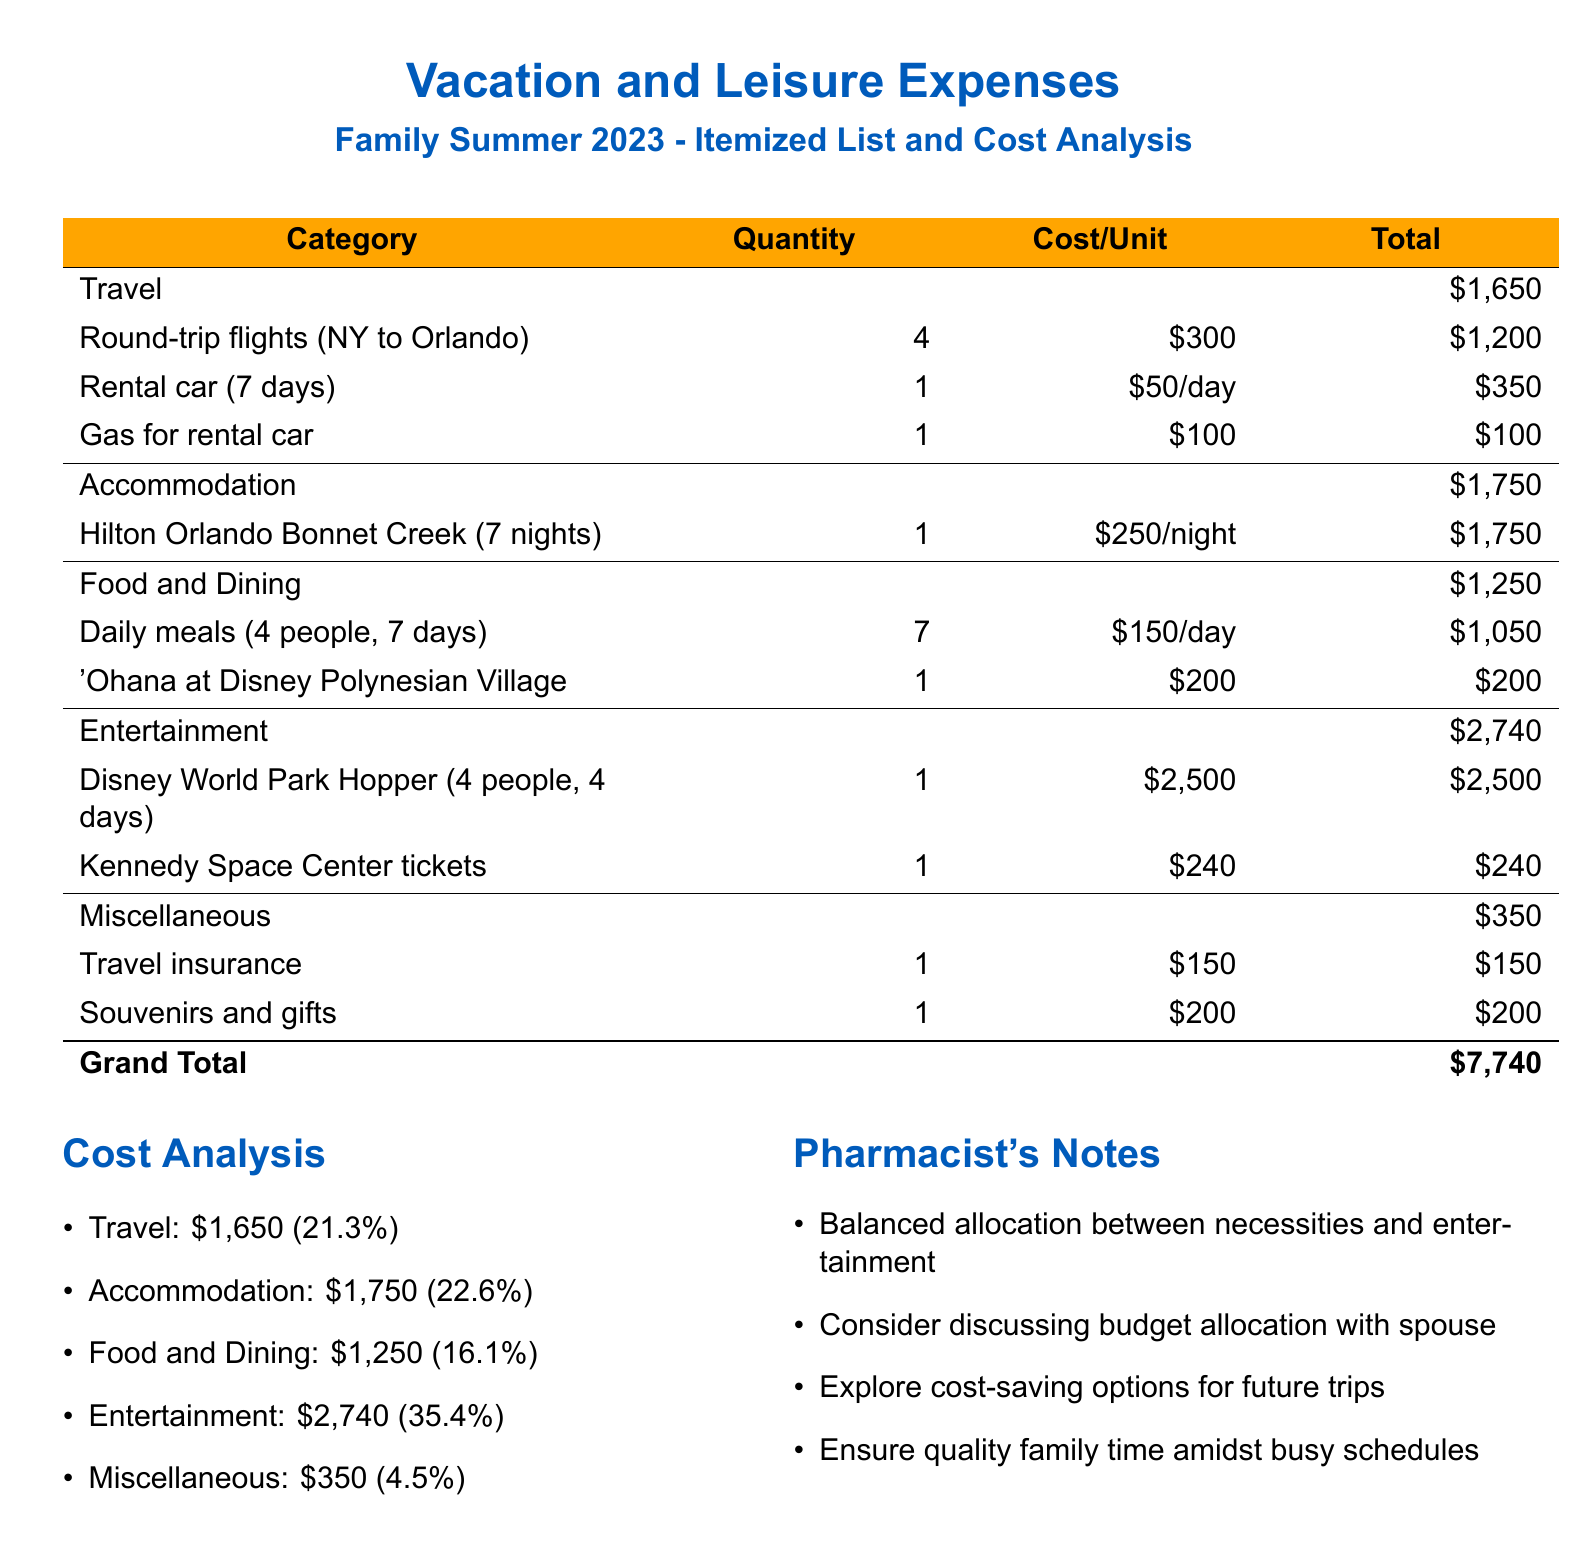What is the total cost of Travel? The total cost of Travel is directly stated in the document, which totals $1,650.
Answer: $1,650 How much was spent on Entertainment? The total spent on Entertainment is indicated in the cost analysis, which is $2,740.
Answer: $2,740 What was the quantity of Round-trip flights? The document specifies that there were 4 Round-trip flights.
Answer: 4 What percentage of the total expenses is Miscellaneous? The expenses are summarized in a list, and Miscellaneous accounts for 4.5% of the total.
Answer: 4.5% How much did the rental car cost per day? The document breaks down the rental car cost, indicating it was $50 per day.
Answer: $50 What is the Grand Total of the expenses? The Grand Total of the expenses is clearly listed in the table as $7,740.
Answer: $7,740 How many days was the rental car booked for? The rental car was booked for 7 days, as represented in the expenses overview.
Answer: 7 days What type of accommodation was used? The accommodation listed in the document is the Hilton Orlando Bonnet Creek.
Answer: Hilton Orlando Bonnet Creek What was one of the notes made by the pharmacist? One of the notes suggested considering discussing budget allocation with the spouse.
Answer: Discuss budget allocation with spouse 